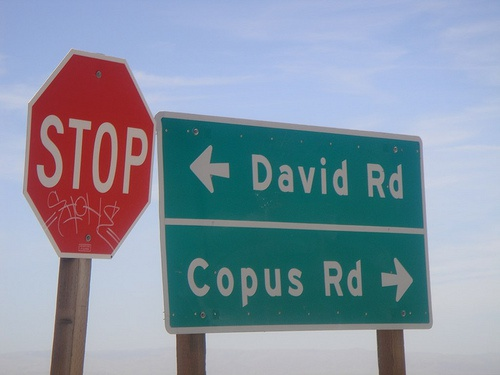Describe the objects in this image and their specific colors. I can see a stop sign in darkgray and brown tones in this image. 